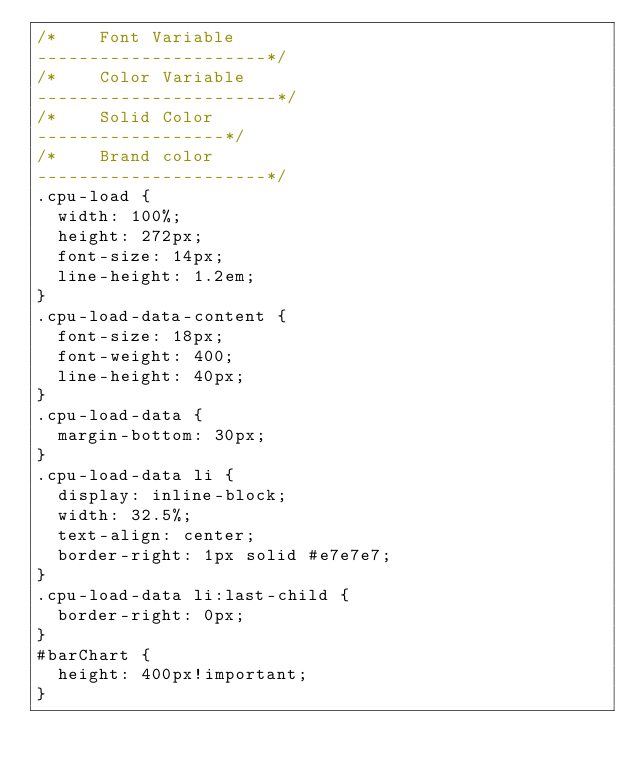<code> <loc_0><loc_0><loc_500><loc_500><_CSS_>/*    Font Variable
----------------------*/
/*    Color Variable
-----------------------*/
/*    Solid Color
------------------*/
/*    Brand color
----------------------*/
.cpu-load {
  width: 100%;
  height: 272px;
  font-size: 14px;
  line-height: 1.2em;
}
.cpu-load-data-content {
  font-size: 18px;
  font-weight: 400;
  line-height: 40px;
}
.cpu-load-data {
  margin-bottom: 30px;
}
.cpu-load-data li {
  display: inline-block;
  width: 32.5%;
  text-align: center;
  border-right: 1px solid #e7e7e7;
}
.cpu-load-data li:last-child {
  border-right: 0px;
}
#barChart {
  height: 400px!important;
}
</code> 